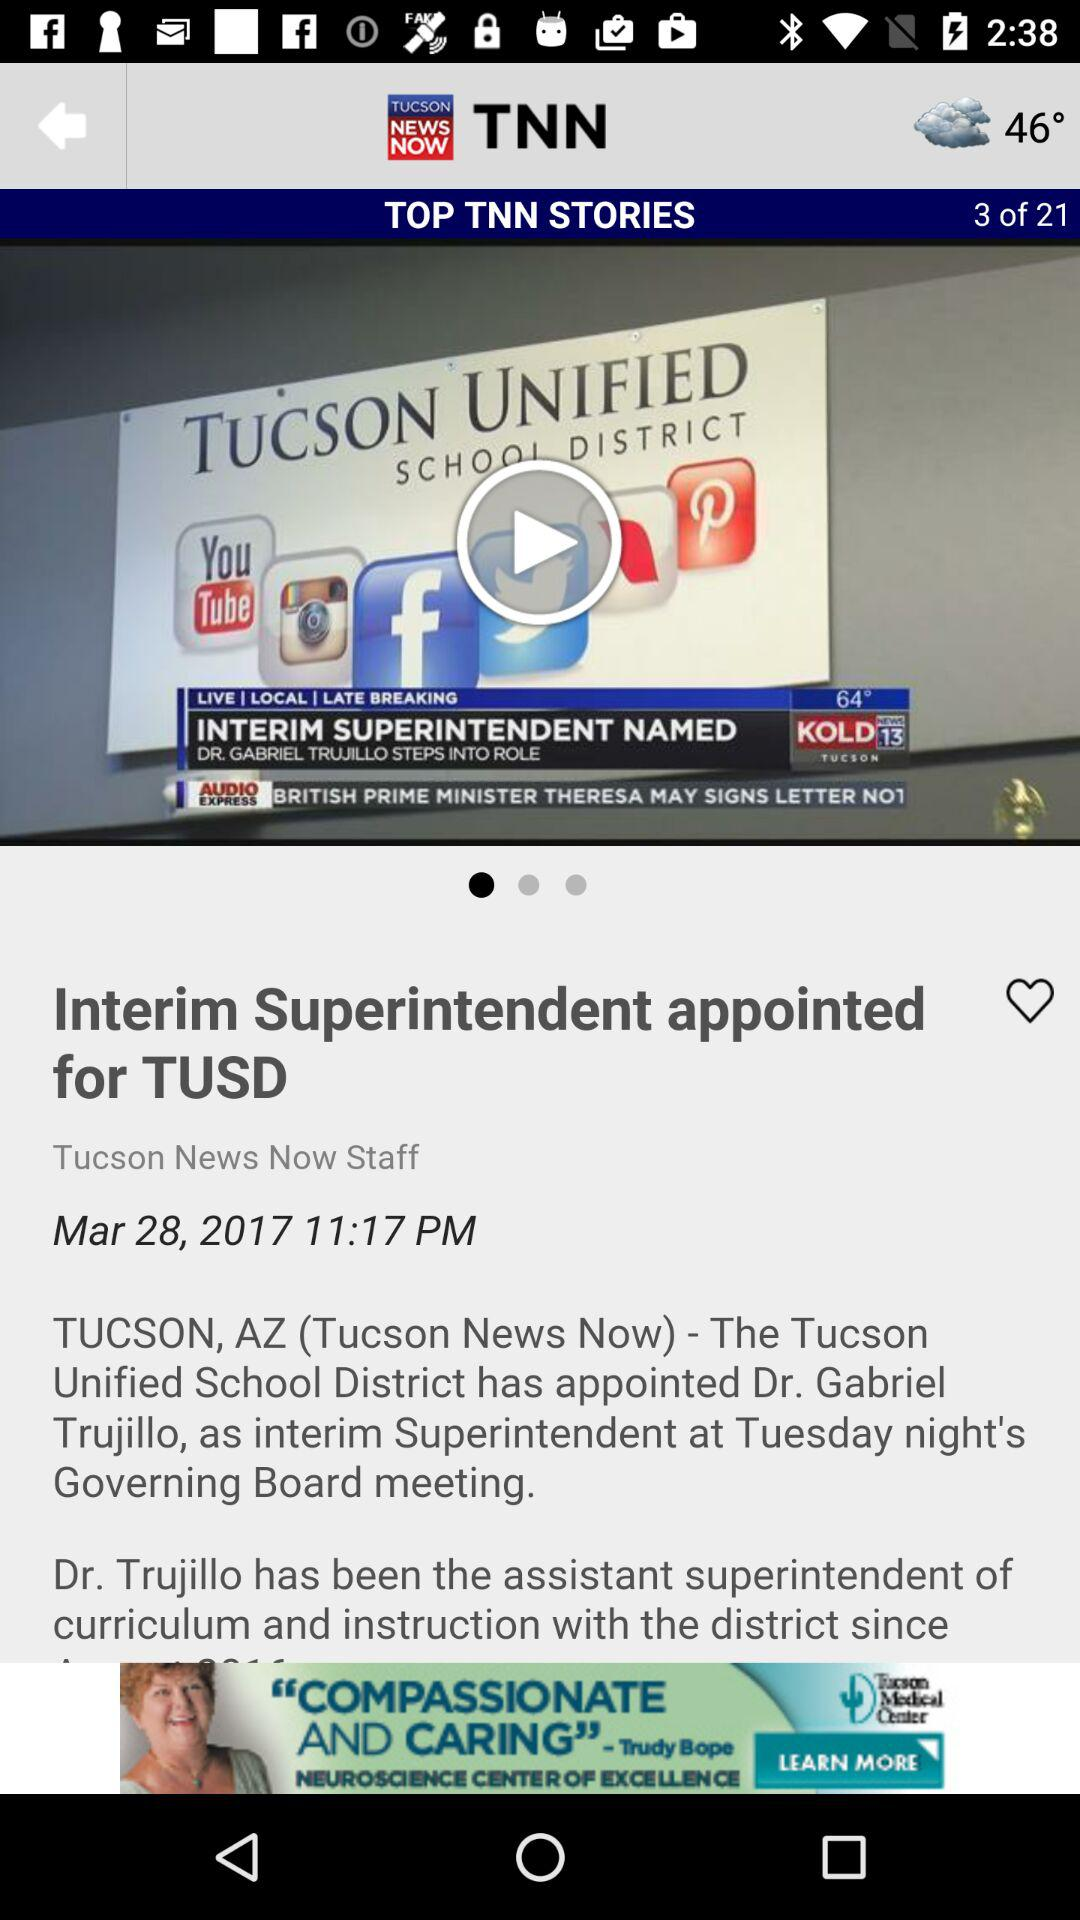What is the name of the news channel? The name of the news channel is "TNN". 